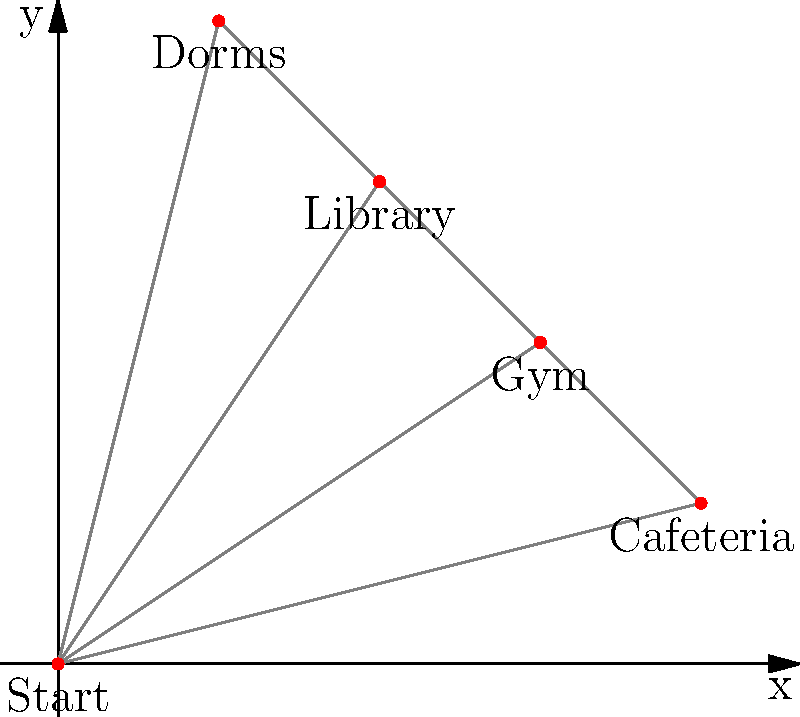As the organizer of a campus tour, you need to plan the most efficient route to visit all locations shown in the map. Starting from the "Start" point, what is the total distance traveled if you visit each location exactly once and return to the starting point, following the shortest possible path? To solve this problem, we'll use the nearest neighbor algorithm, which is a simple heuristic for the Traveling Salesman Problem. Here's the step-by-step solution:

1. Start at the "Start" point (0,0).
2. Find the nearest unvisited location:
   - Distance to Library: $\sqrt{2^2 + 3^2} = \sqrt{13} \approx 3.61$
   - Distance to Cafeteria: $\sqrt{4^2 + 1^2} = \sqrt{17} \approx 4.12$
   - Distance to Dorms: $\sqrt{1^2 + 4^2} = \sqrt{17} \approx 4.12$
   - Distance to Gym: $\sqrt{3^2 + 2^2} = \sqrt{13} \approx 3.61$
   The nearest locations are Library and Gym, both at distance $\sqrt{13}$. Let's choose Library.

3. Move to Library (2,3). Distance traveled: $\sqrt{13}$

4. Find the nearest unvisited location from Library:
   - Distance to Cafeteria: $\sqrt{2^2 + (-2)^2} = \sqrt{8} \approx 2.83$
   - Distance to Dorms: $\sqrt{(-1)^2 + 1^2} = \sqrt{2} \approx 1.41$
   - Distance to Gym: $\sqrt{1^2 + (-1)^2} = \sqrt{2} \approx 1.41$
   The nearest location is Dorms.

5. Move to Dorms (1,4). Distance traveled: $\sqrt{13} + \sqrt{2}$

6. Find the nearest unvisited location from Dorms:
   - Distance to Cafeteria: $\sqrt{3^2 + (-3)^2} = 3\sqrt{2} \approx 4.24$
   - Distance to Gym: $\sqrt{2^2 + (-2)^2} = 2\sqrt{2} \approx 2.83$
   The nearest location is Gym.

7. Move to Gym (3,2). Distance traveled: $\sqrt{13} + \sqrt{2} + 2\sqrt{2}$

8. The only unvisited location is Cafeteria (4,1).

9. Move to Cafeteria (4,1). Distance traveled: $\sqrt{13} + \sqrt{2} + 2\sqrt{2} + \sqrt{2^2 + (-1)^2} = \sqrt{13} + \sqrt{2} + 2\sqrt{2} + \sqrt{5}$

10. Return to Start (0,0). Final distance: $\sqrt{13} + \sqrt{2} + 2\sqrt{2} + \sqrt{5} + \sqrt{4^2 + 1^2} = \sqrt{13} + \sqrt{2} + 2\sqrt{2} + \sqrt{5} + \sqrt{17}$

The total distance traveled is $\sqrt{13} + \sqrt{2} + 2\sqrt{2} + \sqrt{5} + \sqrt{17} \approx 13.86$ units.
Answer: $\sqrt{13} + \sqrt{2} + 2\sqrt{2} + \sqrt{5} + \sqrt{17}$ units 